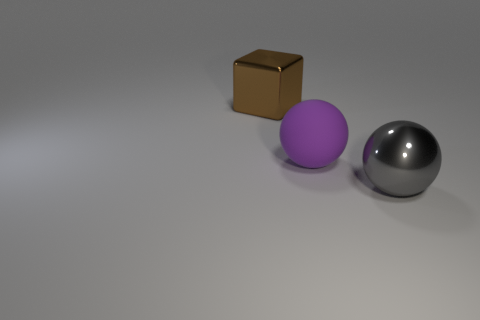Add 1 large objects. How many objects exist? 4 Subtract all balls. How many objects are left? 1 Subtract all big purple matte things. Subtract all big purple matte spheres. How many objects are left? 1 Add 1 gray metallic objects. How many gray metallic objects are left? 2 Add 1 big metal cubes. How many big metal cubes exist? 2 Subtract 0 blue spheres. How many objects are left? 3 